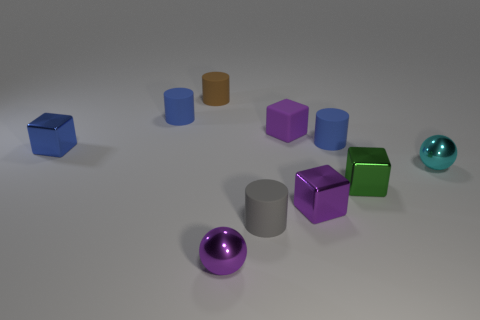How many purple cubes must be subtracted to get 1 purple cubes? 1 Subtract all cubes. How many objects are left? 6 Add 2 green metallic objects. How many green metallic objects exist? 3 Subtract 0 red blocks. How many objects are left? 10 Subtract all small purple balls. Subtract all blocks. How many objects are left? 5 Add 3 matte cubes. How many matte cubes are left? 4 